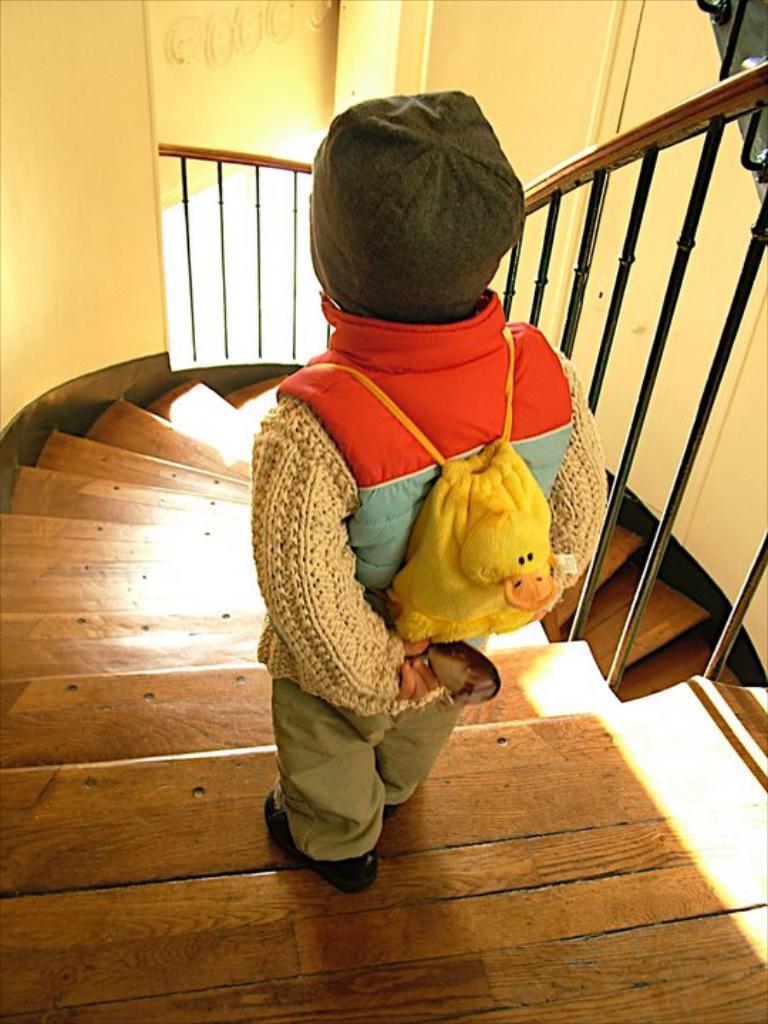How would you summarize this image in a sentence or two? In the image there is a girl in sweatshirt standing on the wooden steps with fence on either side. 